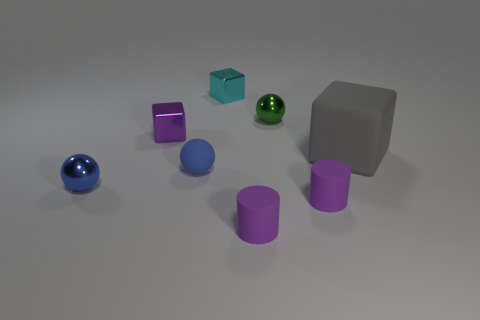How many cyan things have the same shape as the tiny green shiny thing?
Provide a succinct answer. 0. What is the large thing made of?
Your answer should be very brief. Rubber. Is the small blue matte object the same shape as the blue metal thing?
Provide a succinct answer. Yes. Are there any blue spheres that have the same material as the green sphere?
Ensure brevity in your answer.  Yes. What is the color of the tiny sphere that is both right of the purple metallic cube and in front of the gray thing?
Provide a short and direct response. Blue. There is a tiny blue thing that is on the right side of the small blue metal ball; what is its material?
Make the answer very short. Rubber. Is there another gray object that has the same shape as the gray rubber object?
Ensure brevity in your answer.  No. How many other objects are the same shape as the blue matte object?
Your answer should be very brief. 2. Does the small purple metallic object have the same shape as the matte thing behind the rubber sphere?
Provide a succinct answer. Yes. What material is the gray object that is the same shape as the small purple shiny thing?
Ensure brevity in your answer.  Rubber. 